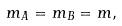<formula> <loc_0><loc_0><loc_500><loc_500>m _ { A } = m _ { B } = m ,</formula> 